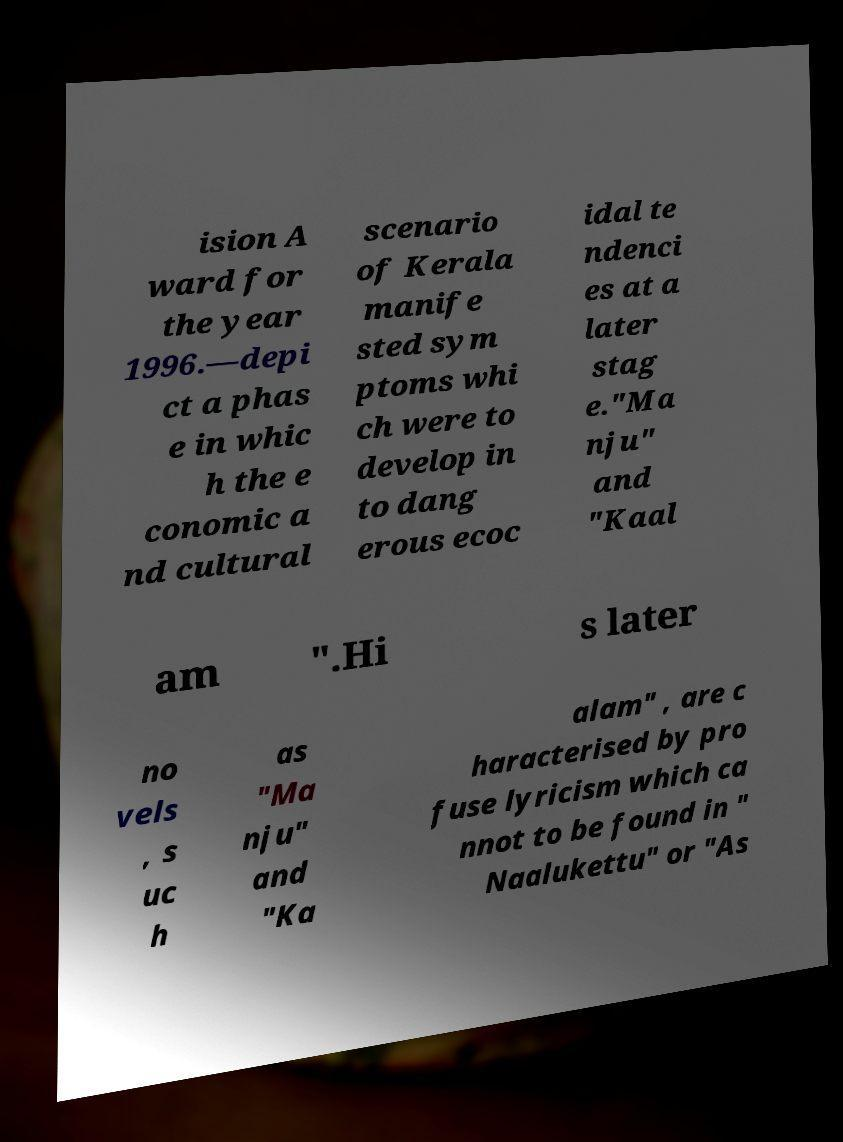I need the written content from this picture converted into text. Can you do that? ision A ward for the year 1996.—depi ct a phas e in whic h the e conomic a nd cultural scenario of Kerala manife sted sym ptoms whi ch were to develop in to dang erous ecoc idal te ndenci es at a later stag e."Ma nju" and "Kaal am ".Hi s later no vels , s uc h as "Ma nju" and "Ka alam" , are c haracterised by pro fuse lyricism which ca nnot to be found in " Naalukettu" or "As 